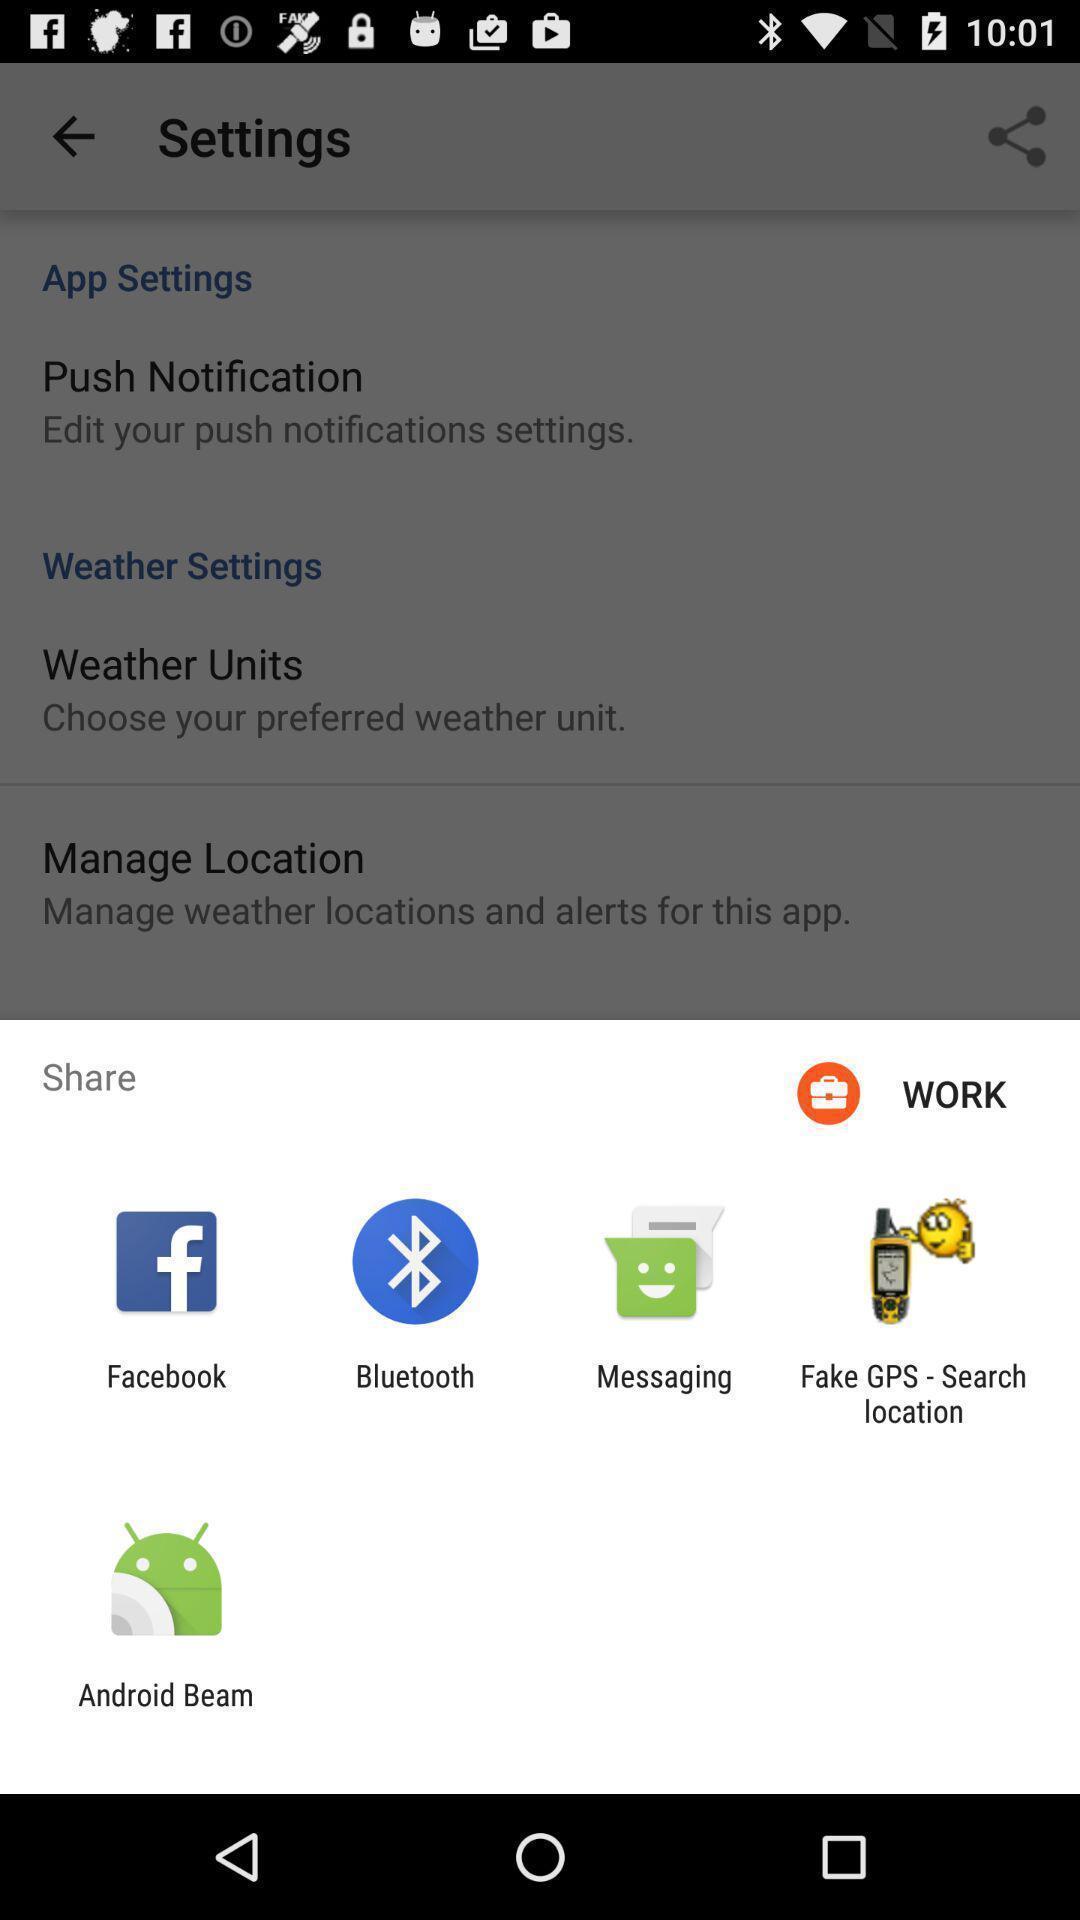Provide a textual representation of this image. Pop-up to choose an app to share. 